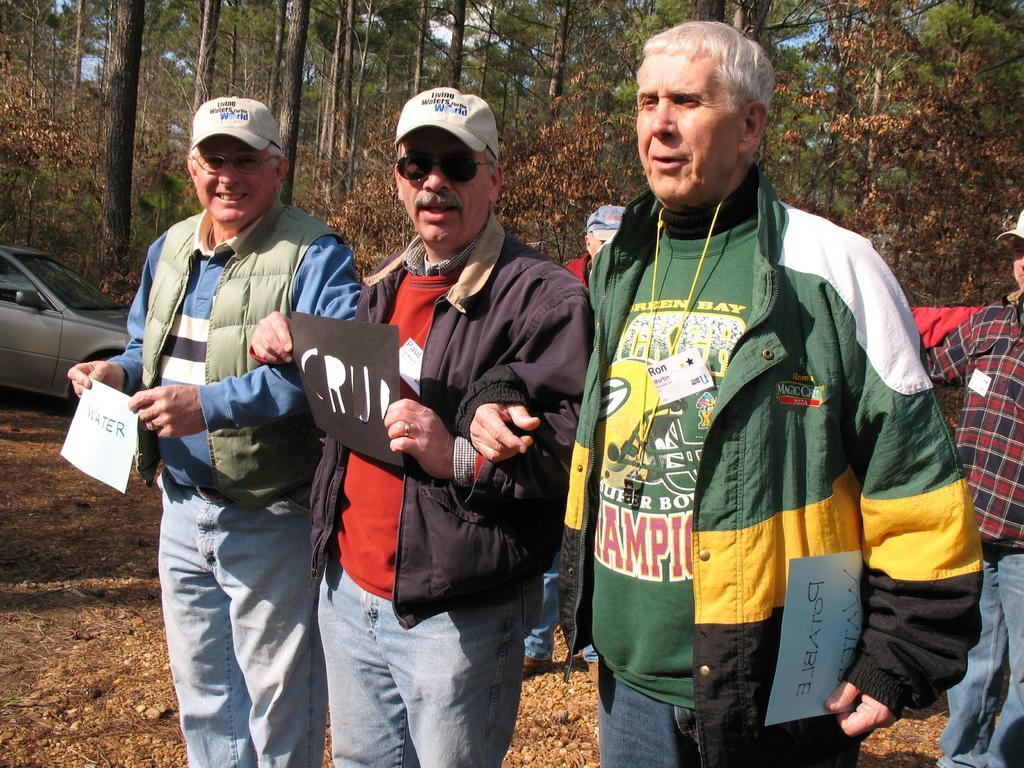Please provide a concise description of this image. In this image in the center there are three persons who are standing and they are holding some papers on the papers there is some text on the right side and in the background there are two more persons on the left side there is one car at the bottom there is sand and in the background there are some trees. 